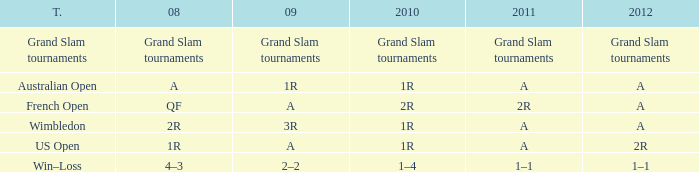Name the tournament when it has 2011 of 2r French Open. 